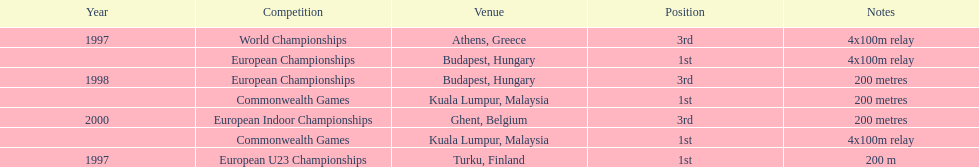How long was the sprint from the european indoor championships competition in 2000? 200 metres. 